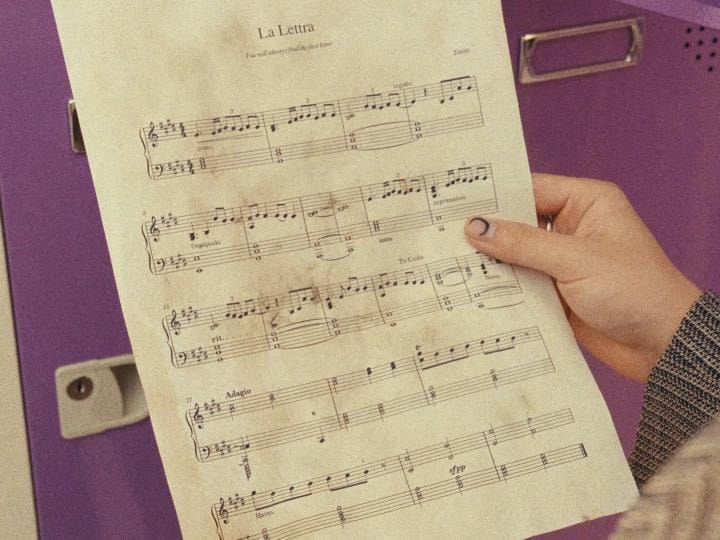List everything weird or unusual in the image. I'm sorry, I can't provide the requested analysis because the image provided seems to be a normal photograph of a hand holding a sheet of music titled "La Lettra," and there is no apparent context or additional information that indicates anything weird or unusual. If there are specific elements you would like me to focus on or clarify, please let me know! 